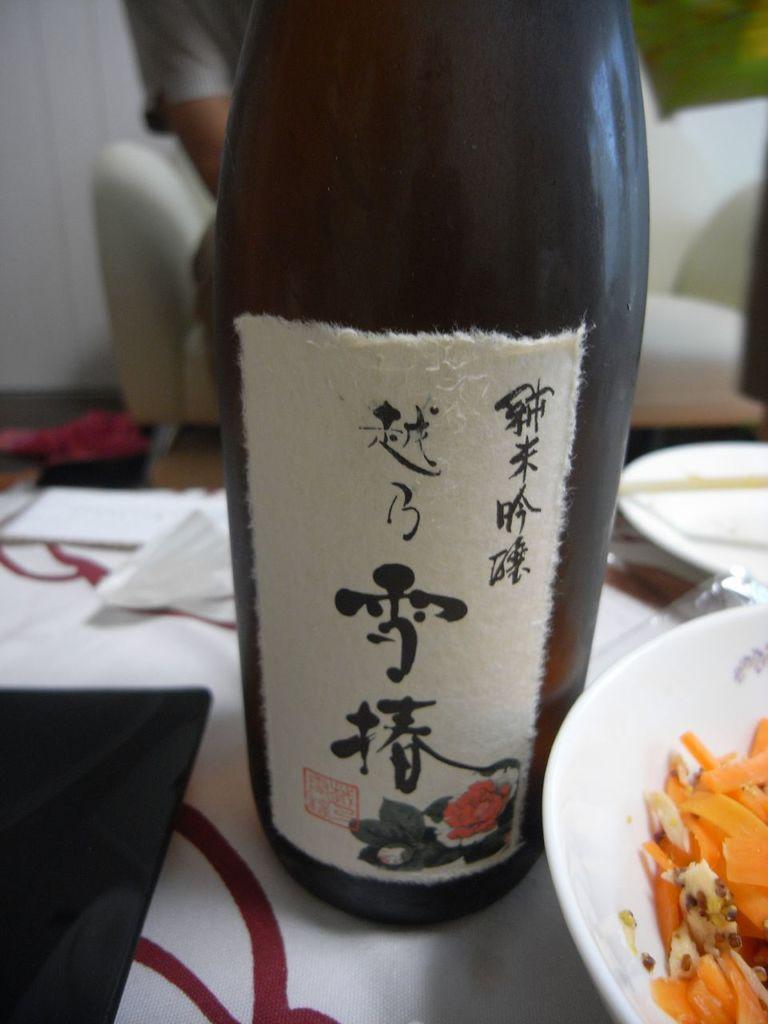Could you give a brief overview of what you see in this image? In the image there is a table and above the table there are few papers, a bottle, a bowl with some food , behind the table there is a sofa and some person is sitting on the sofa. 